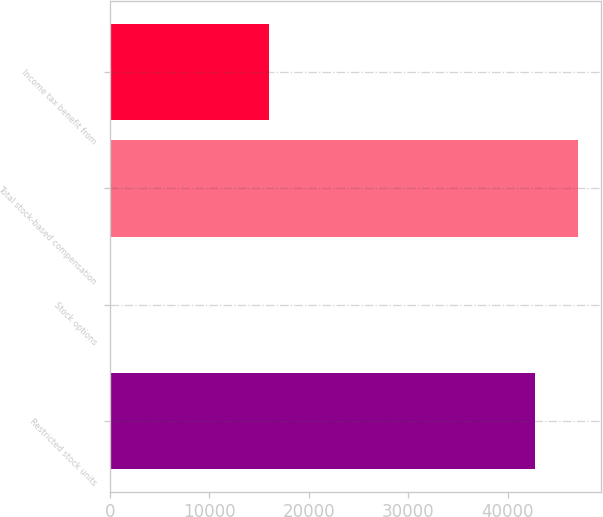<chart> <loc_0><loc_0><loc_500><loc_500><bar_chart><fcel>Restricted stock units<fcel>Stock options<fcel>Total stock-based compensation<fcel>Income tax benefit from<nl><fcel>42733<fcel>156<fcel>47006.3<fcel>16006<nl></chart> 